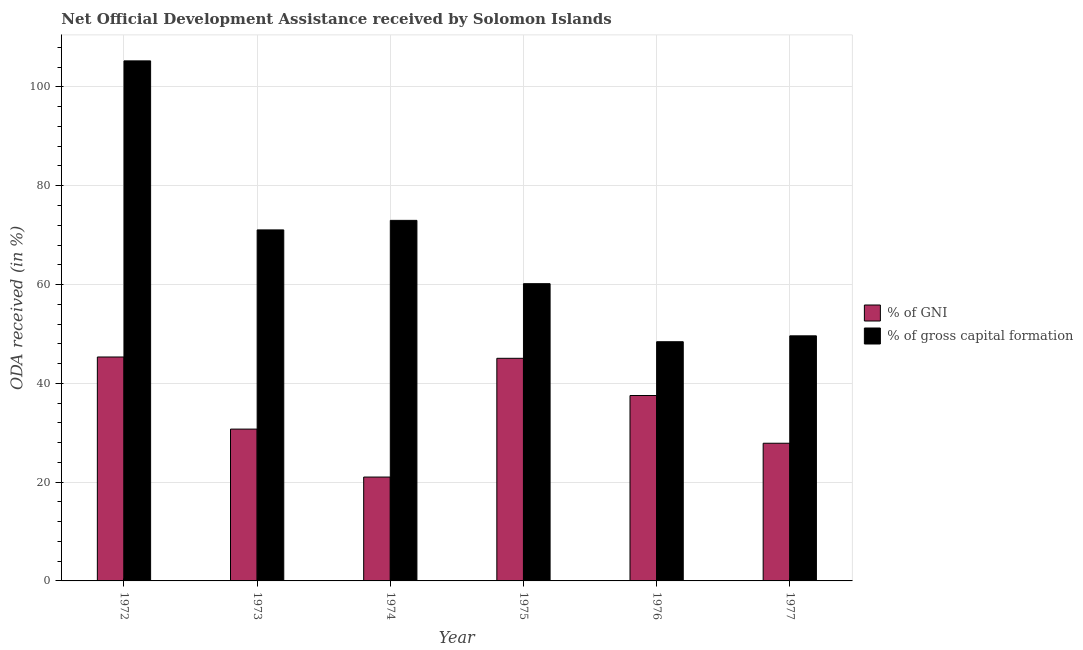How many different coloured bars are there?
Keep it short and to the point. 2. How many groups of bars are there?
Your response must be concise. 6. Are the number of bars per tick equal to the number of legend labels?
Keep it short and to the point. Yes. Are the number of bars on each tick of the X-axis equal?
Offer a very short reply. Yes. How many bars are there on the 2nd tick from the right?
Provide a short and direct response. 2. What is the label of the 2nd group of bars from the left?
Provide a short and direct response. 1973. In how many cases, is the number of bars for a given year not equal to the number of legend labels?
Offer a very short reply. 0. What is the oda received as percentage of gross capital formation in 1972?
Keep it short and to the point. 105.27. Across all years, what is the maximum oda received as percentage of gross capital formation?
Ensure brevity in your answer.  105.27. Across all years, what is the minimum oda received as percentage of gross capital formation?
Make the answer very short. 48.42. In which year was the oda received as percentage of gni minimum?
Your answer should be very brief. 1974. What is the total oda received as percentage of gni in the graph?
Your response must be concise. 207.56. What is the difference between the oda received as percentage of gni in 1972 and that in 1975?
Offer a terse response. 0.26. What is the difference between the oda received as percentage of gni in 1973 and the oda received as percentage of gross capital formation in 1975?
Ensure brevity in your answer.  -14.33. What is the average oda received as percentage of gni per year?
Make the answer very short. 34.59. What is the ratio of the oda received as percentage of gross capital formation in 1972 to that in 1977?
Keep it short and to the point. 2.12. Is the oda received as percentage of gni in 1973 less than that in 1975?
Give a very brief answer. Yes. Is the difference between the oda received as percentage of gross capital formation in 1972 and 1973 greater than the difference between the oda received as percentage of gni in 1972 and 1973?
Your response must be concise. No. What is the difference between the highest and the second highest oda received as percentage of gross capital formation?
Your answer should be compact. 32.29. What is the difference between the highest and the lowest oda received as percentage of gross capital formation?
Ensure brevity in your answer.  56.85. In how many years, is the oda received as percentage of gross capital formation greater than the average oda received as percentage of gross capital formation taken over all years?
Offer a terse response. 3. What does the 1st bar from the left in 1976 represents?
Provide a succinct answer. % of GNI. What does the 2nd bar from the right in 1975 represents?
Offer a very short reply. % of GNI. Are the values on the major ticks of Y-axis written in scientific E-notation?
Offer a terse response. No. Does the graph contain any zero values?
Your answer should be compact. No. Where does the legend appear in the graph?
Ensure brevity in your answer.  Center right. How many legend labels are there?
Offer a very short reply. 2. What is the title of the graph?
Your answer should be compact. Net Official Development Assistance received by Solomon Islands. What is the label or title of the X-axis?
Offer a terse response. Year. What is the label or title of the Y-axis?
Ensure brevity in your answer.  ODA received (in %). What is the ODA received (in %) of % of GNI in 1972?
Provide a succinct answer. 45.33. What is the ODA received (in %) of % of gross capital formation in 1972?
Keep it short and to the point. 105.27. What is the ODA received (in %) of % of GNI in 1973?
Make the answer very short. 30.73. What is the ODA received (in %) in % of gross capital formation in 1973?
Your response must be concise. 71.05. What is the ODA received (in %) in % of GNI in 1974?
Make the answer very short. 21.02. What is the ODA received (in %) of % of gross capital formation in 1974?
Your response must be concise. 72.99. What is the ODA received (in %) of % of GNI in 1975?
Ensure brevity in your answer.  45.07. What is the ODA received (in %) in % of gross capital formation in 1975?
Your response must be concise. 60.17. What is the ODA received (in %) of % of GNI in 1976?
Offer a very short reply. 37.53. What is the ODA received (in %) in % of gross capital formation in 1976?
Your answer should be very brief. 48.42. What is the ODA received (in %) in % of GNI in 1977?
Your answer should be compact. 27.87. What is the ODA received (in %) in % of gross capital formation in 1977?
Your answer should be very brief. 49.61. Across all years, what is the maximum ODA received (in %) in % of GNI?
Provide a short and direct response. 45.33. Across all years, what is the maximum ODA received (in %) in % of gross capital formation?
Your answer should be compact. 105.27. Across all years, what is the minimum ODA received (in %) in % of GNI?
Your answer should be very brief. 21.02. Across all years, what is the minimum ODA received (in %) in % of gross capital formation?
Your answer should be very brief. 48.42. What is the total ODA received (in %) of % of GNI in the graph?
Your answer should be very brief. 207.56. What is the total ODA received (in %) in % of gross capital formation in the graph?
Your response must be concise. 407.52. What is the difference between the ODA received (in %) in % of GNI in 1972 and that in 1973?
Keep it short and to the point. 14.6. What is the difference between the ODA received (in %) in % of gross capital formation in 1972 and that in 1973?
Offer a very short reply. 34.22. What is the difference between the ODA received (in %) of % of GNI in 1972 and that in 1974?
Keep it short and to the point. 24.31. What is the difference between the ODA received (in %) in % of gross capital formation in 1972 and that in 1974?
Keep it short and to the point. 32.29. What is the difference between the ODA received (in %) of % of GNI in 1972 and that in 1975?
Offer a terse response. 0.26. What is the difference between the ODA received (in %) of % of gross capital formation in 1972 and that in 1975?
Keep it short and to the point. 45.1. What is the difference between the ODA received (in %) of % of GNI in 1972 and that in 1976?
Your answer should be very brief. 7.8. What is the difference between the ODA received (in %) in % of gross capital formation in 1972 and that in 1976?
Offer a terse response. 56.85. What is the difference between the ODA received (in %) in % of GNI in 1972 and that in 1977?
Make the answer very short. 17.46. What is the difference between the ODA received (in %) in % of gross capital formation in 1972 and that in 1977?
Keep it short and to the point. 55.66. What is the difference between the ODA received (in %) in % of GNI in 1973 and that in 1974?
Your answer should be compact. 9.71. What is the difference between the ODA received (in %) in % of gross capital formation in 1973 and that in 1974?
Give a very brief answer. -1.93. What is the difference between the ODA received (in %) of % of GNI in 1973 and that in 1975?
Offer a very short reply. -14.33. What is the difference between the ODA received (in %) in % of gross capital formation in 1973 and that in 1975?
Ensure brevity in your answer.  10.88. What is the difference between the ODA received (in %) in % of GNI in 1973 and that in 1976?
Give a very brief answer. -6.8. What is the difference between the ODA received (in %) of % of gross capital formation in 1973 and that in 1976?
Offer a very short reply. 22.63. What is the difference between the ODA received (in %) of % of GNI in 1973 and that in 1977?
Make the answer very short. 2.86. What is the difference between the ODA received (in %) in % of gross capital formation in 1973 and that in 1977?
Keep it short and to the point. 21.44. What is the difference between the ODA received (in %) in % of GNI in 1974 and that in 1975?
Provide a succinct answer. -24.04. What is the difference between the ODA received (in %) of % of gross capital formation in 1974 and that in 1975?
Give a very brief answer. 12.82. What is the difference between the ODA received (in %) of % of GNI in 1974 and that in 1976?
Make the answer very short. -16.51. What is the difference between the ODA received (in %) of % of gross capital formation in 1974 and that in 1976?
Give a very brief answer. 24.57. What is the difference between the ODA received (in %) in % of GNI in 1974 and that in 1977?
Give a very brief answer. -6.85. What is the difference between the ODA received (in %) of % of gross capital formation in 1974 and that in 1977?
Offer a terse response. 23.37. What is the difference between the ODA received (in %) of % of GNI in 1975 and that in 1976?
Keep it short and to the point. 7.53. What is the difference between the ODA received (in %) of % of gross capital formation in 1975 and that in 1976?
Provide a short and direct response. 11.75. What is the difference between the ODA received (in %) in % of GNI in 1975 and that in 1977?
Give a very brief answer. 17.2. What is the difference between the ODA received (in %) in % of gross capital formation in 1975 and that in 1977?
Give a very brief answer. 10.56. What is the difference between the ODA received (in %) in % of GNI in 1976 and that in 1977?
Ensure brevity in your answer.  9.66. What is the difference between the ODA received (in %) in % of gross capital formation in 1976 and that in 1977?
Offer a terse response. -1.19. What is the difference between the ODA received (in %) in % of GNI in 1972 and the ODA received (in %) in % of gross capital formation in 1973?
Ensure brevity in your answer.  -25.73. What is the difference between the ODA received (in %) in % of GNI in 1972 and the ODA received (in %) in % of gross capital formation in 1974?
Give a very brief answer. -27.66. What is the difference between the ODA received (in %) in % of GNI in 1972 and the ODA received (in %) in % of gross capital formation in 1975?
Your answer should be compact. -14.84. What is the difference between the ODA received (in %) in % of GNI in 1972 and the ODA received (in %) in % of gross capital formation in 1976?
Your response must be concise. -3.09. What is the difference between the ODA received (in %) of % of GNI in 1972 and the ODA received (in %) of % of gross capital formation in 1977?
Ensure brevity in your answer.  -4.28. What is the difference between the ODA received (in %) of % of GNI in 1973 and the ODA received (in %) of % of gross capital formation in 1974?
Give a very brief answer. -42.25. What is the difference between the ODA received (in %) of % of GNI in 1973 and the ODA received (in %) of % of gross capital formation in 1975?
Give a very brief answer. -29.44. What is the difference between the ODA received (in %) of % of GNI in 1973 and the ODA received (in %) of % of gross capital formation in 1976?
Keep it short and to the point. -17.69. What is the difference between the ODA received (in %) in % of GNI in 1973 and the ODA received (in %) in % of gross capital formation in 1977?
Offer a very short reply. -18.88. What is the difference between the ODA received (in %) of % of GNI in 1974 and the ODA received (in %) of % of gross capital formation in 1975?
Your answer should be compact. -39.15. What is the difference between the ODA received (in %) of % of GNI in 1974 and the ODA received (in %) of % of gross capital formation in 1976?
Your response must be concise. -27.4. What is the difference between the ODA received (in %) of % of GNI in 1974 and the ODA received (in %) of % of gross capital formation in 1977?
Your answer should be very brief. -28.59. What is the difference between the ODA received (in %) in % of GNI in 1975 and the ODA received (in %) in % of gross capital formation in 1976?
Give a very brief answer. -3.35. What is the difference between the ODA received (in %) of % of GNI in 1975 and the ODA received (in %) of % of gross capital formation in 1977?
Offer a terse response. -4.55. What is the difference between the ODA received (in %) of % of GNI in 1976 and the ODA received (in %) of % of gross capital formation in 1977?
Your answer should be compact. -12.08. What is the average ODA received (in %) of % of GNI per year?
Keep it short and to the point. 34.59. What is the average ODA received (in %) in % of gross capital formation per year?
Offer a terse response. 67.92. In the year 1972, what is the difference between the ODA received (in %) in % of GNI and ODA received (in %) in % of gross capital formation?
Provide a short and direct response. -59.94. In the year 1973, what is the difference between the ODA received (in %) in % of GNI and ODA received (in %) in % of gross capital formation?
Your answer should be compact. -40.32. In the year 1974, what is the difference between the ODA received (in %) of % of GNI and ODA received (in %) of % of gross capital formation?
Keep it short and to the point. -51.96. In the year 1975, what is the difference between the ODA received (in %) in % of GNI and ODA received (in %) in % of gross capital formation?
Offer a terse response. -15.1. In the year 1976, what is the difference between the ODA received (in %) in % of GNI and ODA received (in %) in % of gross capital formation?
Provide a short and direct response. -10.89. In the year 1977, what is the difference between the ODA received (in %) of % of GNI and ODA received (in %) of % of gross capital formation?
Provide a succinct answer. -21.74. What is the ratio of the ODA received (in %) of % of GNI in 1972 to that in 1973?
Provide a succinct answer. 1.47. What is the ratio of the ODA received (in %) of % of gross capital formation in 1972 to that in 1973?
Make the answer very short. 1.48. What is the ratio of the ODA received (in %) of % of GNI in 1972 to that in 1974?
Provide a short and direct response. 2.16. What is the ratio of the ODA received (in %) of % of gross capital formation in 1972 to that in 1974?
Offer a very short reply. 1.44. What is the ratio of the ODA received (in %) of % of GNI in 1972 to that in 1975?
Your answer should be very brief. 1.01. What is the ratio of the ODA received (in %) of % of gross capital formation in 1972 to that in 1975?
Your answer should be compact. 1.75. What is the ratio of the ODA received (in %) of % of GNI in 1972 to that in 1976?
Give a very brief answer. 1.21. What is the ratio of the ODA received (in %) of % of gross capital formation in 1972 to that in 1976?
Give a very brief answer. 2.17. What is the ratio of the ODA received (in %) in % of GNI in 1972 to that in 1977?
Your answer should be very brief. 1.63. What is the ratio of the ODA received (in %) of % of gross capital formation in 1972 to that in 1977?
Provide a succinct answer. 2.12. What is the ratio of the ODA received (in %) of % of GNI in 1973 to that in 1974?
Provide a succinct answer. 1.46. What is the ratio of the ODA received (in %) of % of gross capital formation in 1973 to that in 1974?
Your answer should be compact. 0.97. What is the ratio of the ODA received (in %) of % of GNI in 1973 to that in 1975?
Offer a terse response. 0.68. What is the ratio of the ODA received (in %) in % of gross capital formation in 1973 to that in 1975?
Your answer should be very brief. 1.18. What is the ratio of the ODA received (in %) of % of GNI in 1973 to that in 1976?
Provide a short and direct response. 0.82. What is the ratio of the ODA received (in %) of % of gross capital formation in 1973 to that in 1976?
Your answer should be very brief. 1.47. What is the ratio of the ODA received (in %) in % of GNI in 1973 to that in 1977?
Give a very brief answer. 1.1. What is the ratio of the ODA received (in %) in % of gross capital formation in 1973 to that in 1977?
Provide a succinct answer. 1.43. What is the ratio of the ODA received (in %) in % of GNI in 1974 to that in 1975?
Keep it short and to the point. 0.47. What is the ratio of the ODA received (in %) of % of gross capital formation in 1974 to that in 1975?
Offer a very short reply. 1.21. What is the ratio of the ODA received (in %) in % of GNI in 1974 to that in 1976?
Your answer should be very brief. 0.56. What is the ratio of the ODA received (in %) in % of gross capital formation in 1974 to that in 1976?
Keep it short and to the point. 1.51. What is the ratio of the ODA received (in %) of % of GNI in 1974 to that in 1977?
Provide a short and direct response. 0.75. What is the ratio of the ODA received (in %) of % of gross capital formation in 1974 to that in 1977?
Keep it short and to the point. 1.47. What is the ratio of the ODA received (in %) of % of GNI in 1975 to that in 1976?
Your response must be concise. 1.2. What is the ratio of the ODA received (in %) in % of gross capital formation in 1975 to that in 1976?
Ensure brevity in your answer.  1.24. What is the ratio of the ODA received (in %) in % of GNI in 1975 to that in 1977?
Your answer should be compact. 1.62. What is the ratio of the ODA received (in %) of % of gross capital formation in 1975 to that in 1977?
Make the answer very short. 1.21. What is the ratio of the ODA received (in %) of % of GNI in 1976 to that in 1977?
Give a very brief answer. 1.35. What is the ratio of the ODA received (in %) of % of gross capital formation in 1976 to that in 1977?
Your answer should be compact. 0.98. What is the difference between the highest and the second highest ODA received (in %) of % of GNI?
Your answer should be very brief. 0.26. What is the difference between the highest and the second highest ODA received (in %) in % of gross capital formation?
Ensure brevity in your answer.  32.29. What is the difference between the highest and the lowest ODA received (in %) in % of GNI?
Give a very brief answer. 24.31. What is the difference between the highest and the lowest ODA received (in %) in % of gross capital formation?
Your answer should be compact. 56.85. 